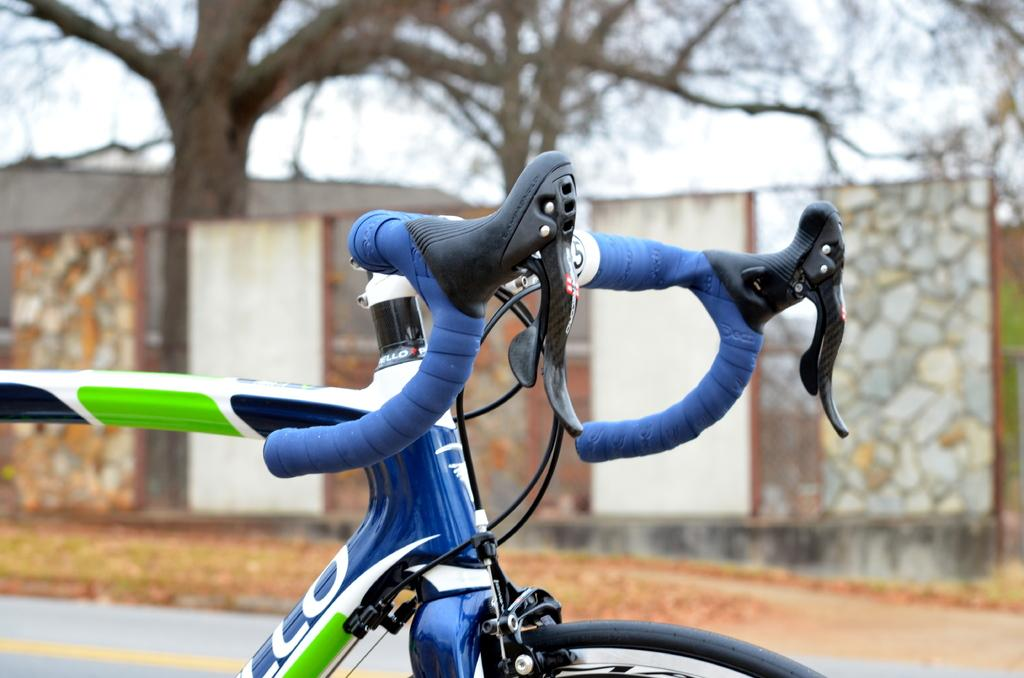What is the main object in the image? There is a bicycle in the image. What can be seen in the background of the image? There is a wall, a tree, and the sky visible in the background of the image. What type of earth can be seen in the image? There is no specific type of earth mentioned or visible in the image. The image features a bicycle, a wall, a tree, and the sky in the background. 